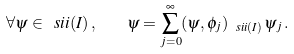Convert formula to latex. <formula><loc_0><loc_0><loc_500><loc_500>\forall \psi \in \ s i i ( I ) \, , \quad \psi = \sum _ { j = 0 } ^ { \infty } ( \psi , \phi _ { j } ) _ { \ s i i ( I ) } \, \psi _ { j } \, .</formula> 